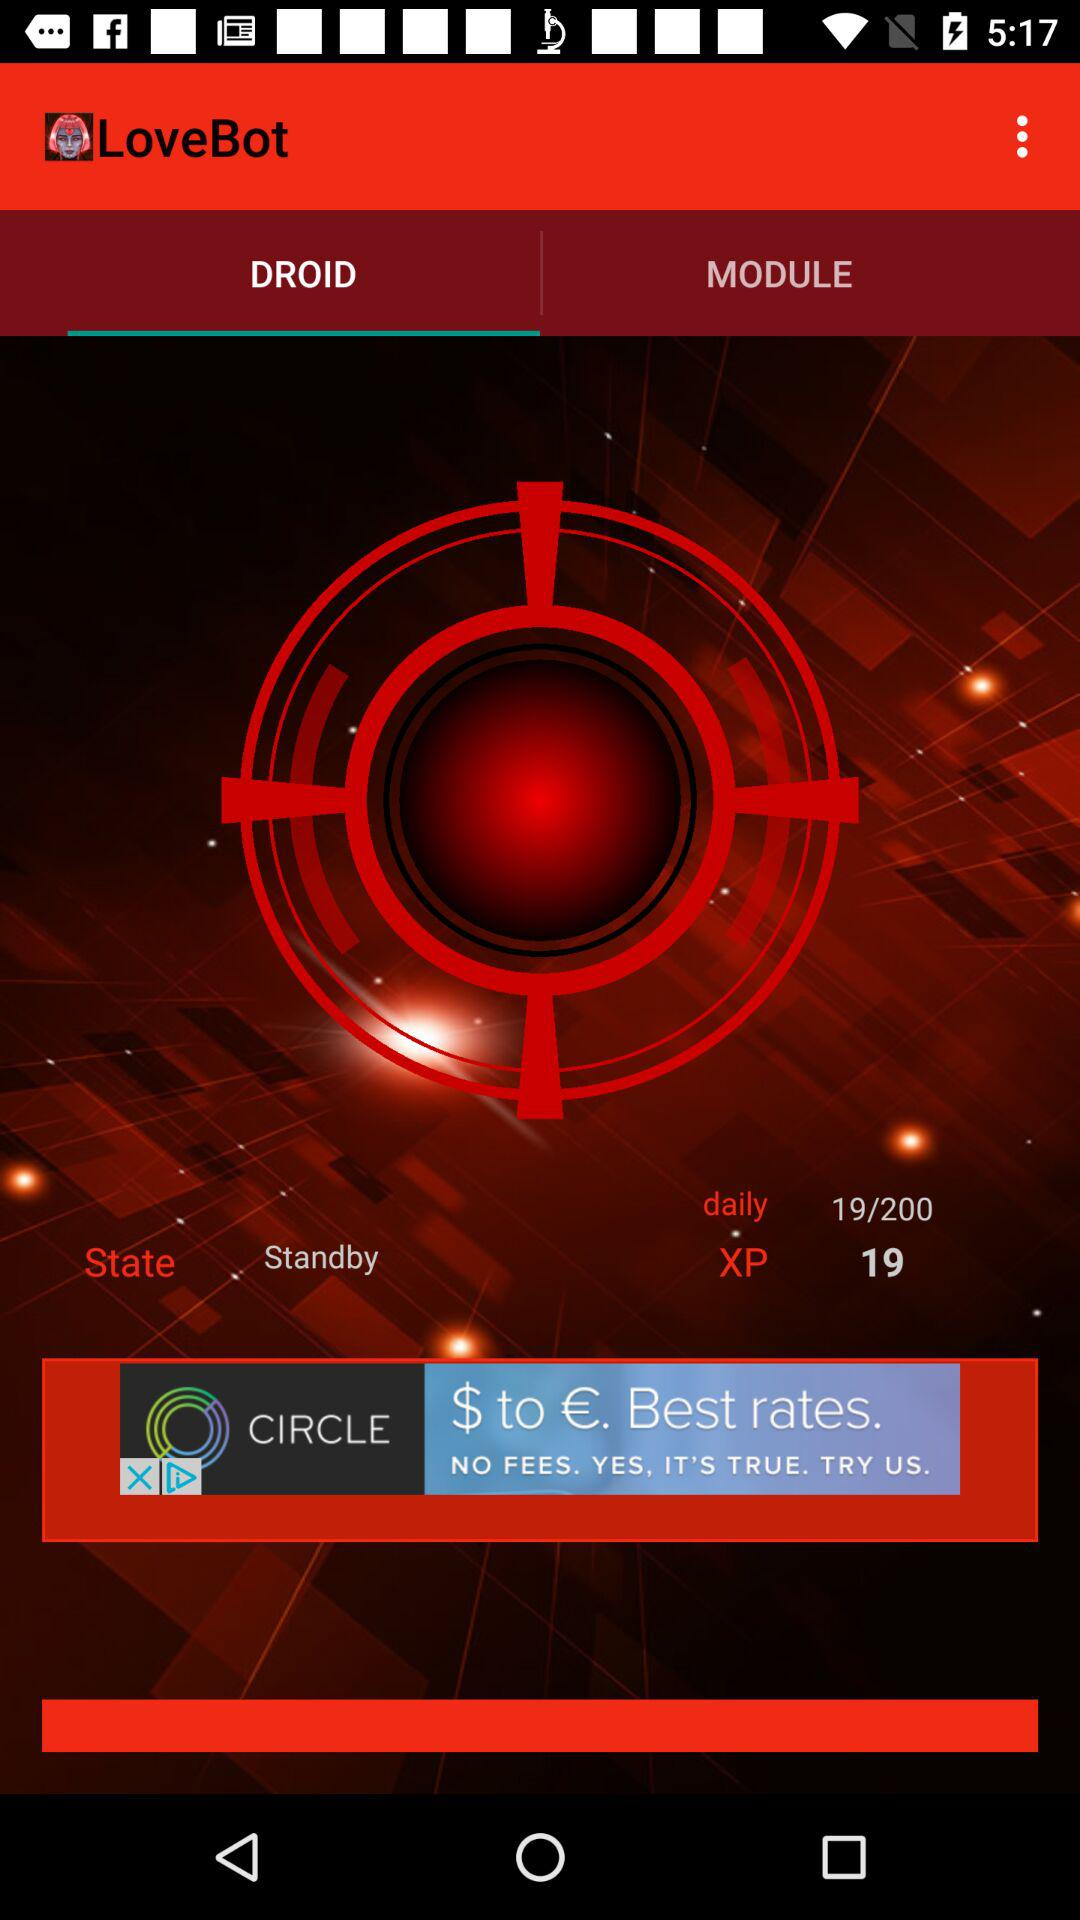What is the state? The state is "Standby". 